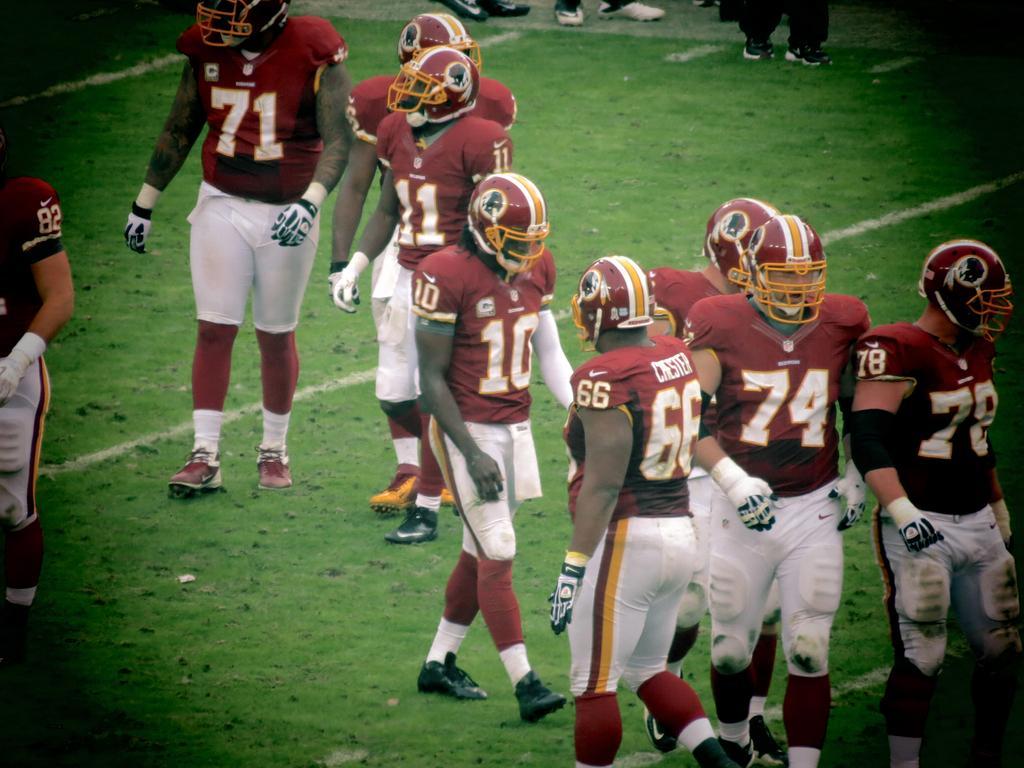Could you give a brief overview of what you see in this image? This picture is taken in the playground. In this image, we can see a group of people are walking on the grass. In the corners, we can see black color. 